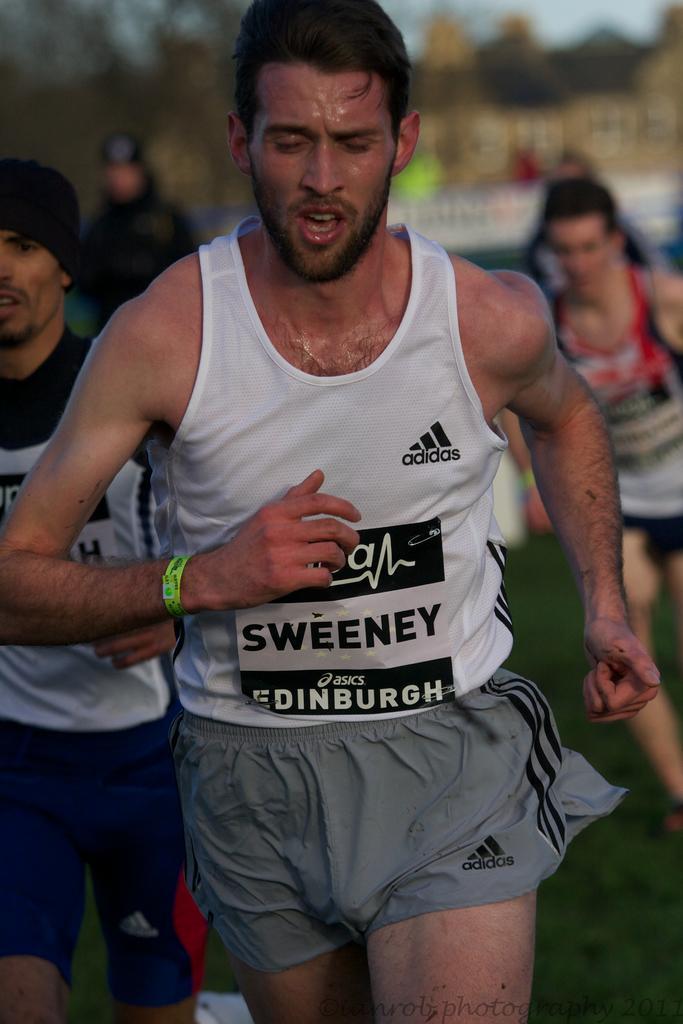Can you describe this image briefly? In this image there are people running, in the background it is blurred. 